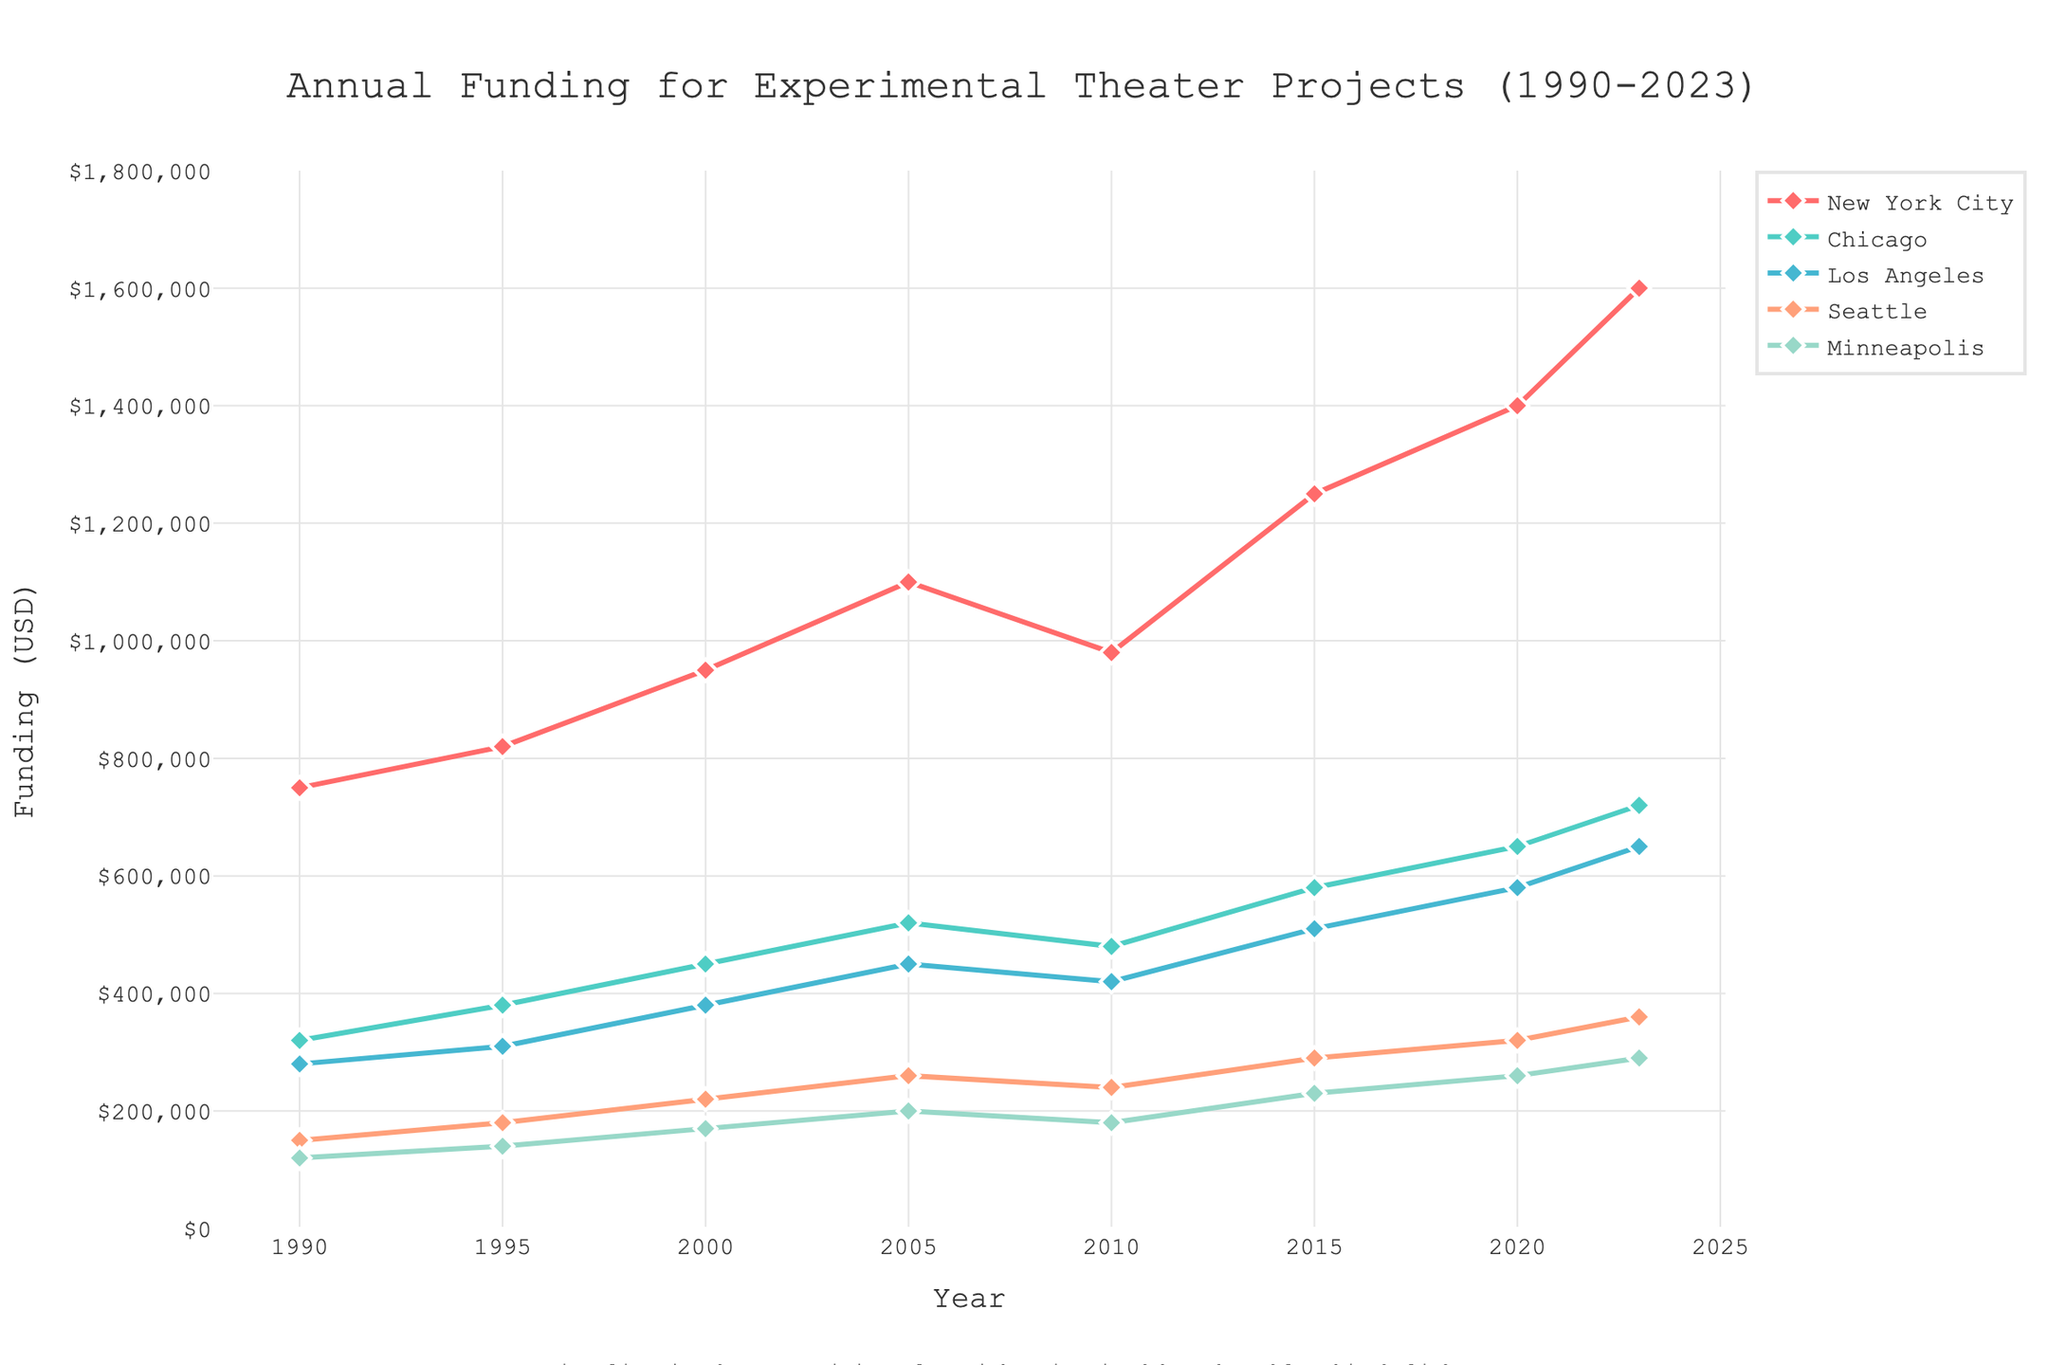What trend is observable in the annual funding allocation for New York City from 1990 to 2023? The line representing New York City's funding increases steadily from 1990 to 2023, with the funding rising from $750,000 to $1,600,000. This indicates an overall upward trend in the allocation of funds over the years.
Answer: Upward trend How does the funding in Seattle in 2015 compare to that in 1990? The funding for Seattle in 1990 is $150,000, whereas in 2015, it is $290,000. By subtracting, we find that the funding increased by $140,000 over this period.
Answer: Increased by $140,000 Which city received the least amount of funding in 2020, and how much was it? Observing the figure for 2020, Minneapolis received the least amount of funding at $260,000.
Answer: Minneapolis, $260,000 What is the average annual funding for Los Angeles from 1990 to 2023? To find the average annual funding for Los Angeles, sum the amounts for each year and divide by the number of years: 
(280,000 + 310,000 + 380,000 + 450,000 + 420,000 + 510,000 + 580,000 + 650,000) / 8 = 3,580,000 / 8 = 447,500.
Answer: $447,500 In which year did New York City first surpass $1,000,000 in annual funding? Observing the New York City line, it first surpasses $1,000,000 between 2000 and 2005. Therefore, it surpassed $1,000,000 in 2005.
Answer: 2005 Compare the funding trends of Chicago and Los Angeles from 1990 to 2023. Both Chicago and Los Angeles show a general upward trend in funding. However, Chicago always remains slightly higher than Los Angeles throughout the years. Both cities experience funding increases but at a different rate.
Answer: Both upward, Chicago is higher Was there any year where funding for Los Angeles decreased compared to the previous year? Yes, from 2005 to 2010, funding for Los Angeles decreased from $450,000 to $420,000, indicating a drop.
Answer: Yes, 2005-2010 By how much did funding for Minneapolis increase from 1990 to 2023? The funding for Minneapolis in 1990 was $120,000 and in 2023 it was $290,000. The increase is calculated by subtracting the 1990 value from the 2023 value: $290,000 - $120,000 = $170,000.
Answer: $170,000 